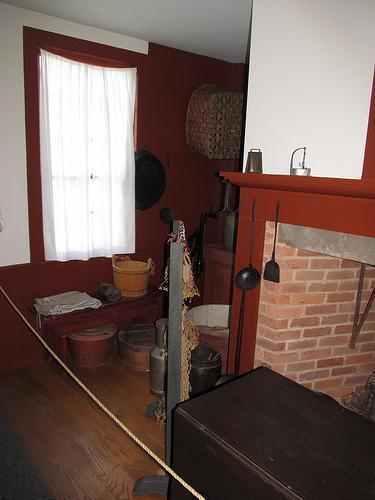How many windows are visible?
Give a very brief answer. 1. 